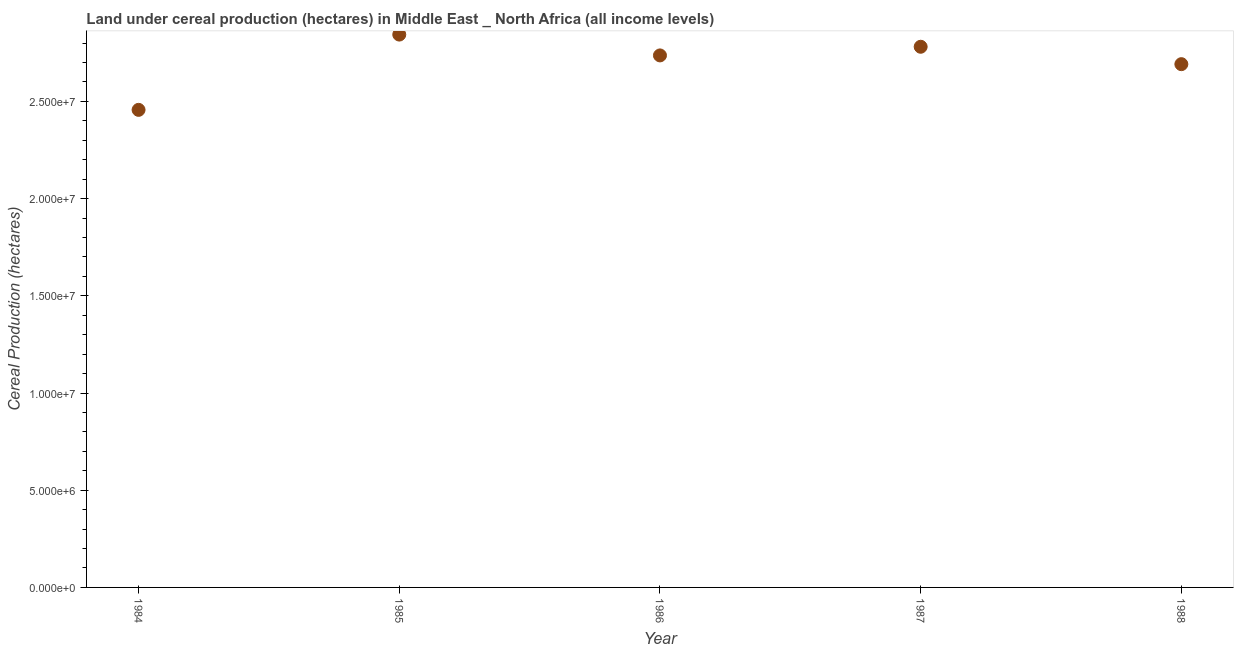What is the land under cereal production in 1988?
Provide a short and direct response. 2.69e+07. Across all years, what is the maximum land under cereal production?
Provide a short and direct response. 2.84e+07. Across all years, what is the minimum land under cereal production?
Keep it short and to the point. 2.46e+07. In which year was the land under cereal production maximum?
Make the answer very short. 1985. What is the sum of the land under cereal production?
Provide a short and direct response. 1.35e+08. What is the difference between the land under cereal production in 1984 and 1988?
Your answer should be very brief. -2.35e+06. What is the average land under cereal production per year?
Offer a very short reply. 2.70e+07. What is the median land under cereal production?
Provide a succinct answer. 2.74e+07. In how many years, is the land under cereal production greater than 8000000 hectares?
Ensure brevity in your answer.  5. Do a majority of the years between 1986 and 1984 (inclusive) have land under cereal production greater than 26000000 hectares?
Offer a terse response. No. What is the ratio of the land under cereal production in 1985 to that in 1986?
Your answer should be compact. 1.04. Is the land under cereal production in 1984 less than that in 1987?
Offer a terse response. Yes. Is the difference between the land under cereal production in 1985 and 1986 greater than the difference between any two years?
Provide a succinct answer. No. What is the difference between the highest and the second highest land under cereal production?
Provide a short and direct response. 6.26e+05. Is the sum of the land under cereal production in 1987 and 1988 greater than the maximum land under cereal production across all years?
Ensure brevity in your answer.  Yes. What is the difference between the highest and the lowest land under cereal production?
Keep it short and to the point. 3.87e+06. Does the land under cereal production monotonically increase over the years?
Your answer should be compact. No. How many dotlines are there?
Offer a very short reply. 1. How many years are there in the graph?
Give a very brief answer. 5. Are the values on the major ticks of Y-axis written in scientific E-notation?
Keep it short and to the point. Yes. Does the graph contain any zero values?
Ensure brevity in your answer.  No. What is the title of the graph?
Ensure brevity in your answer.  Land under cereal production (hectares) in Middle East _ North Africa (all income levels). What is the label or title of the Y-axis?
Give a very brief answer. Cereal Production (hectares). What is the Cereal Production (hectares) in 1984?
Your answer should be very brief. 2.46e+07. What is the Cereal Production (hectares) in 1985?
Offer a very short reply. 2.84e+07. What is the Cereal Production (hectares) in 1986?
Your response must be concise. 2.74e+07. What is the Cereal Production (hectares) in 1987?
Give a very brief answer. 2.78e+07. What is the Cereal Production (hectares) in 1988?
Your response must be concise. 2.69e+07. What is the difference between the Cereal Production (hectares) in 1984 and 1985?
Keep it short and to the point. -3.87e+06. What is the difference between the Cereal Production (hectares) in 1984 and 1986?
Provide a short and direct response. -2.80e+06. What is the difference between the Cereal Production (hectares) in 1984 and 1987?
Give a very brief answer. -3.25e+06. What is the difference between the Cereal Production (hectares) in 1984 and 1988?
Make the answer very short. -2.35e+06. What is the difference between the Cereal Production (hectares) in 1985 and 1986?
Keep it short and to the point. 1.07e+06. What is the difference between the Cereal Production (hectares) in 1985 and 1987?
Provide a succinct answer. 6.26e+05. What is the difference between the Cereal Production (hectares) in 1985 and 1988?
Give a very brief answer. 1.52e+06. What is the difference between the Cereal Production (hectares) in 1986 and 1987?
Offer a terse response. -4.45e+05. What is the difference between the Cereal Production (hectares) in 1986 and 1988?
Offer a very short reply. 4.50e+05. What is the difference between the Cereal Production (hectares) in 1987 and 1988?
Give a very brief answer. 8.95e+05. What is the ratio of the Cereal Production (hectares) in 1984 to that in 1985?
Ensure brevity in your answer.  0.86. What is the ratio of the Cereal Production (hectares) in 1984 to that in 1986?
Your response must be concise. 0.9. What is the ratio of the Cereal Production (hectares) in 1984 to that in 1987?
Ensure brevity in your answer.  0.88. What is the ratio of the Cereal Production (hectares) in 1985 to that in 1986?
Ensure brevity in your answer.  1.04. What is the ratio of the Cereal Production (hectares) in 1985 to that in 1987?
Offer a terse response. 1.02. What is the ratio of the Cereal Production (hectares) in 1985 to that in 1988?
Your answer should be very brief. 1.06. What is the ratio of the Cereal Production (hectares) in 1986 to that in 1987?
Provide a short and direct response. 0.98. What is the ratio of the Cereal Production (hectares) in 1987 to that in 1988?
Offer a terse response. 1.03. 